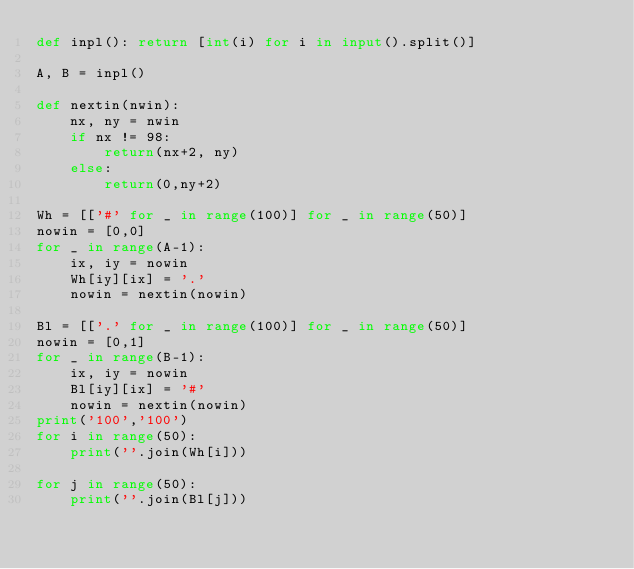<code> <loc_0><loc_0><loc_500><loc_500><_Python_>def inpl(): return [int(i) for i in input().split()]

A, B = inpl()

def nextin(nwin):
    nx, ny = nwin
    if nx != 98:
        return(nx+2, ny)
    else:
        return(0,ny+2)

Wh = [['#' for _ in range(100)] for _ in range(50)]
nowin = [0,0]
for _ in range(A-1):
    ix, iy = nowin
    Wh[iy][ix] = '.'
    nowin = nextin(nowin)

Bl = [['.' for _ in range(100)] for _ in range(50)]
nowin = [0,1]
for _ in range(B-1):
    ix, iy = nowin
    Bl[iy][ix] = '#'
    nowin = nextin(nowin)
print('100','100')
for i in range(50):
    print(''.join(Wh[i]))

for j in range(50):
    print(''.join(Bl[j]))
    </code> 